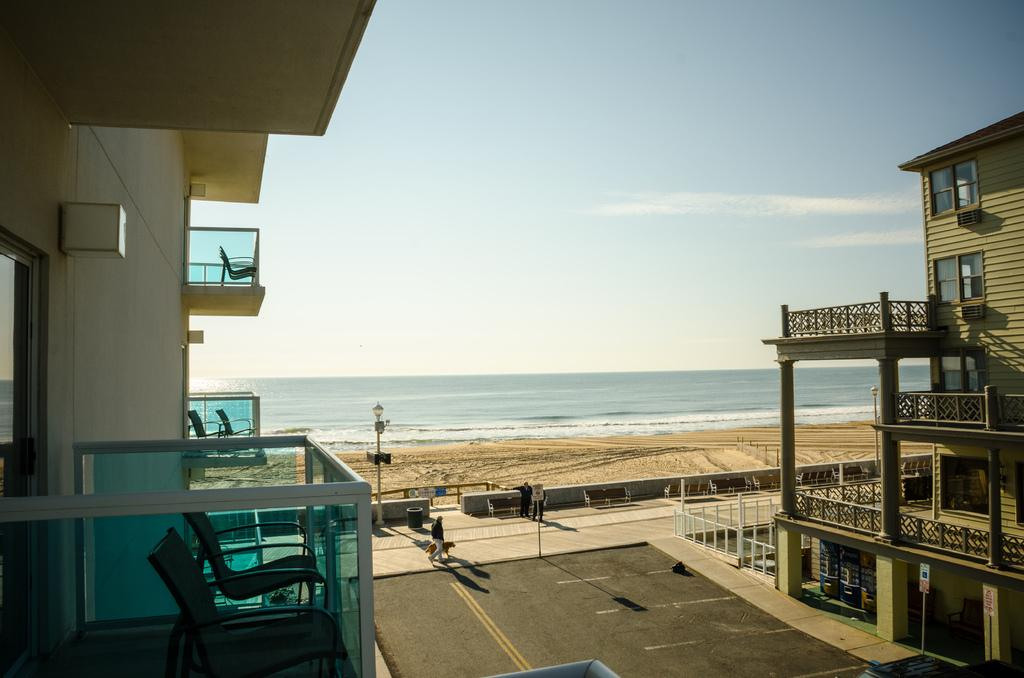What type of structures can be seen in the image? There are buildings in the image. What other objects are present in the image? There are poles and chairs visible in the image. Can you describe the people in the image? There is a group of people in the image. What can be seen in the background of the image? There is water visible in the background of the image. What type of tax is being discussed by the people in the image? There is no indication in the image that the people are discussing any type of tax. 